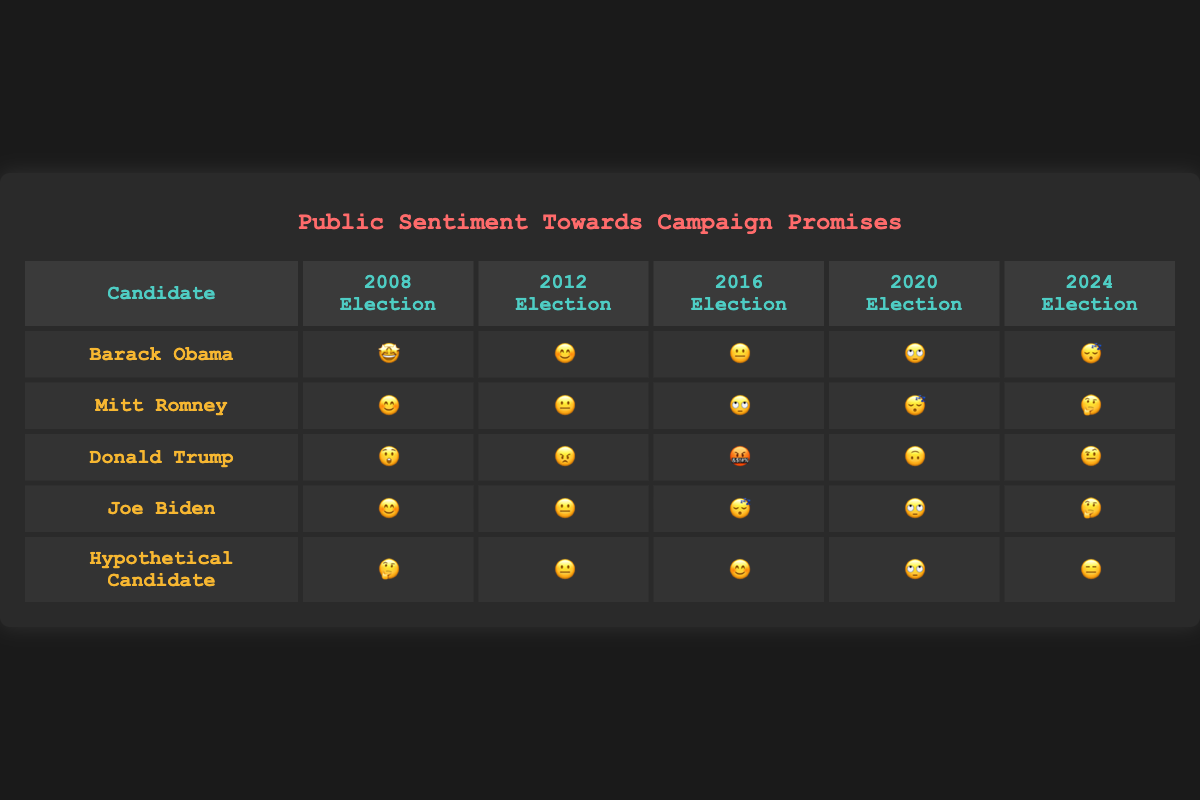What is the title of the chart? The title of the chart can be found at the top, above the table. It is "Public Sentiment Towards Campaign Promises".
Answer: Public Sentiment Towards Campaign Promises Which candidate has the most negative sentiment in the 2016 Election? By looking at the emoji in the 2016 Election column, we can see that Donald Trump has the emoji "🤬", which represents the most negative sentiment compared to the other candidates.
Answer: Donald Trump Did Joe Biden's public sentiment improve or worsen from the 2012 Election to the 2020 Election? In the 2012 Election, Joe Biden has the "😐" emoji, and in the 2020 Election, he has the "🙄" emoji. The "🙄" emoji represents a more negative sentiment than the "😐" emoji. Therefore, the sentiment worsened.
Answer: Worsen What's the sentiment trend for Mitt Romney, and is there any improvement over time? Starting from the 2008 Election, Mitt Romney's sentiments are "😊", "😐", "🙄", "😴", and "🤔". He initially starts positive, worsens over time but shows a slight improvement ("🤔") in the 2024 Election.
Answer: Yes, slight improvement Which candidate starts with a neutral sentiment and ends with a negative sentiment by the 2024 Election? By looking at the sentiment trend, Mitt Romney starts with "😊" near neutral and ends with "🤔" which is more negative.
Answer: Mitt Romney Who has the most variation in public sentiment across all elections? To see the candidate with the most variation, we need to observe the different emojis each has over time. Donald Trump has "😲", "😠", "🤬", "🙃", and "🤨", showing a wide range from shock to anger to confusion.
Answer: Donald Trump Which election year shows the most positive sentiment overall? Looking at each column for the most positive emojis, "2008 Election" has emojis like "😊" and "🤩", indicating the most positive sentiment across candidates.
Answer: 2008 Election How does the hypothetical candidate's sentiment in the 2024 Election compare to Barack Obama's? In 2024, the hypothetical candidate has the "😑" emoji, while Barack Obama has "😴". "😑" (indifference) is slightly more positive than "😴" (bored).
Answer: More positive 